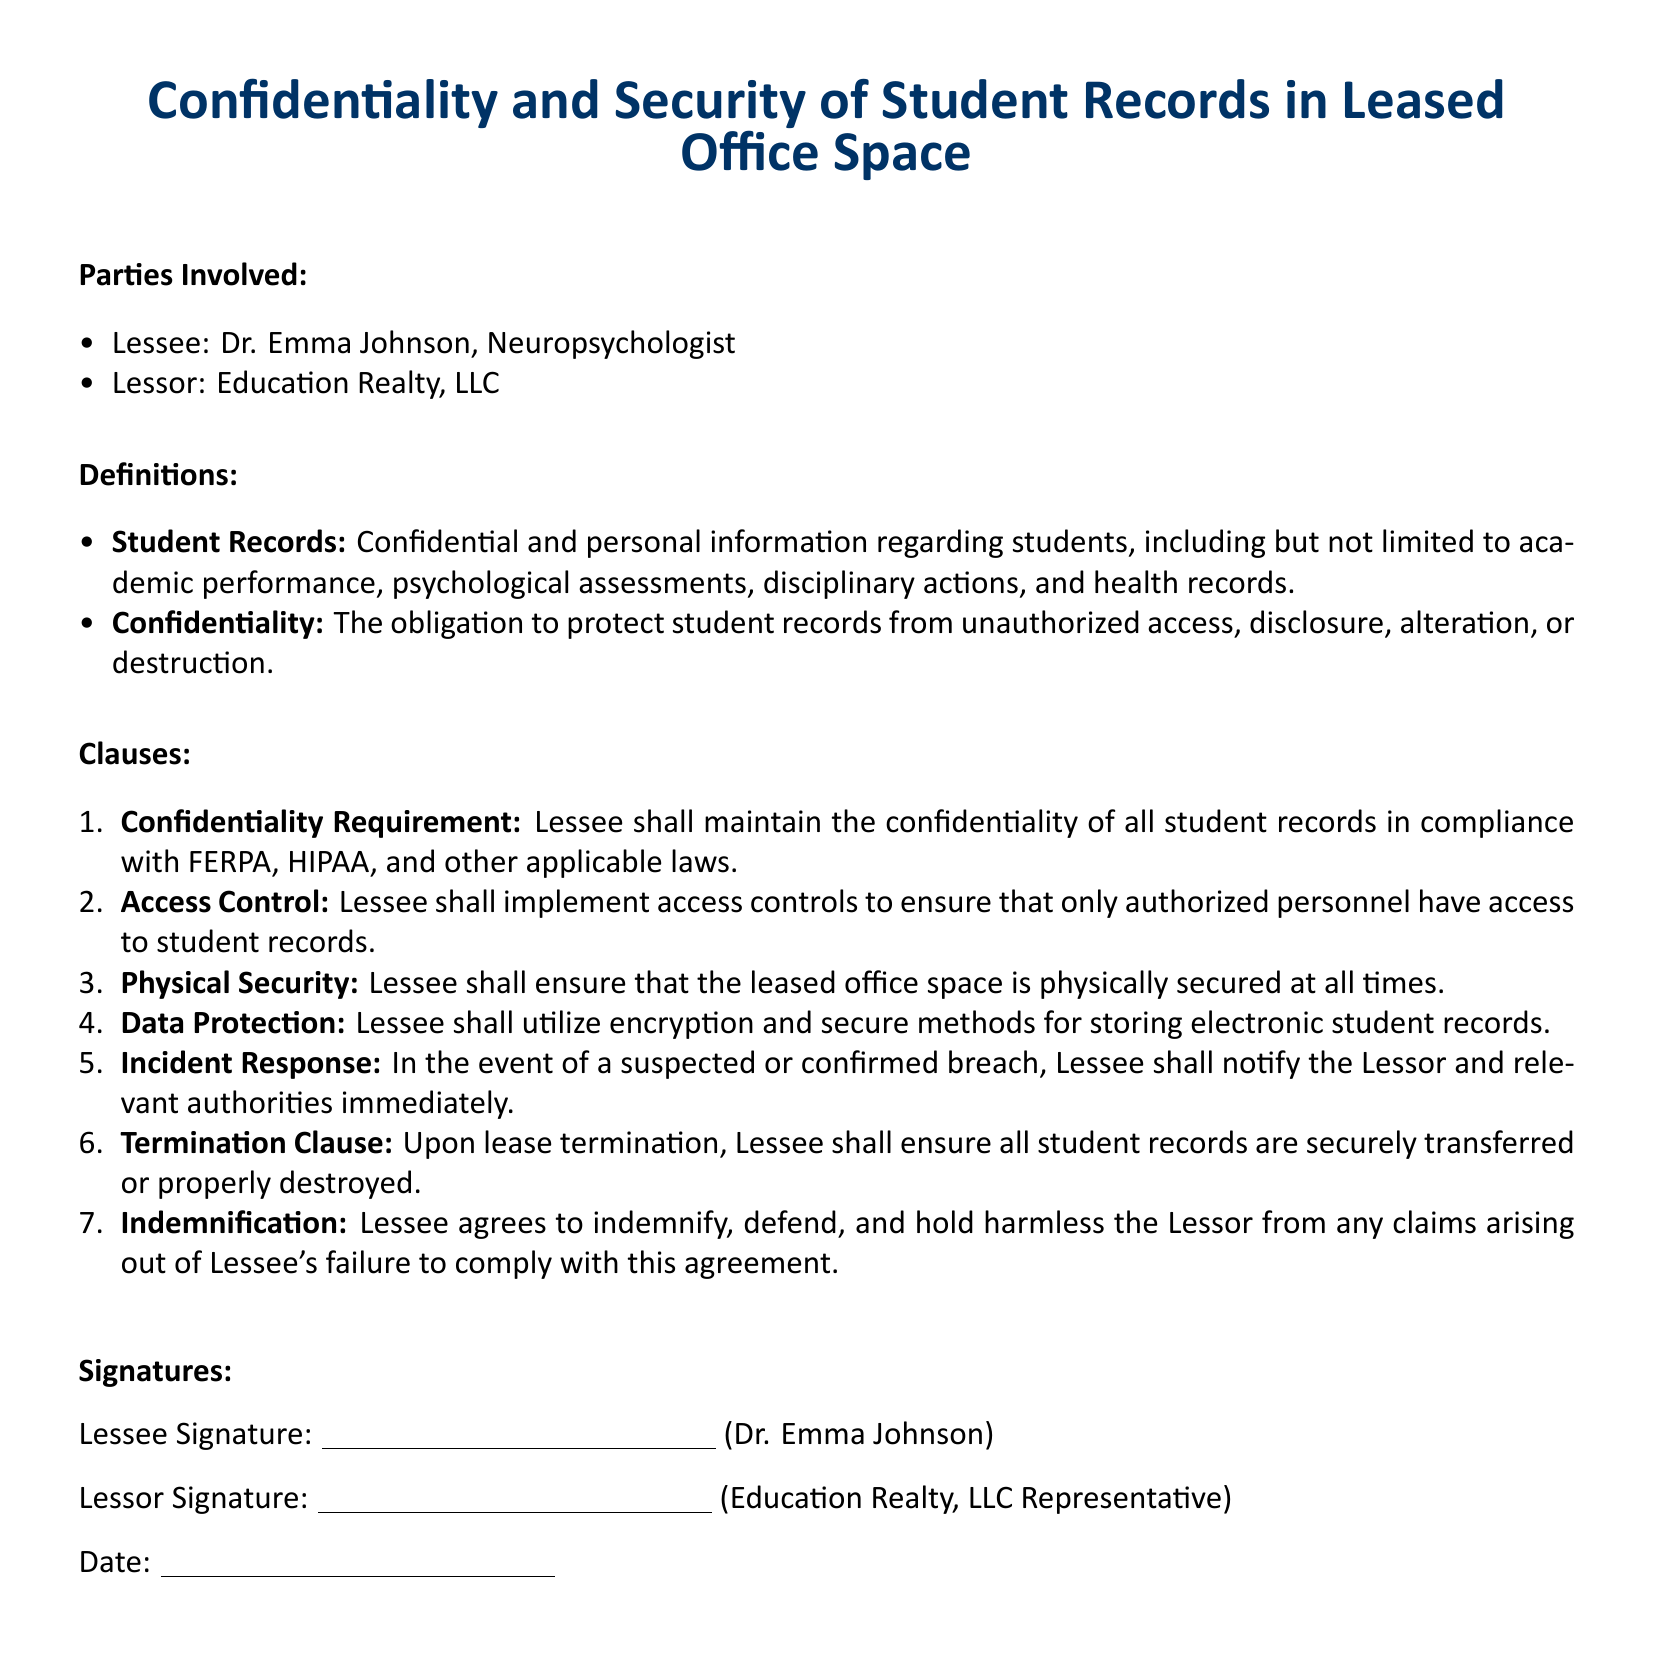What is the name of the Lessee? The Lessee is Dr. Emma Johnson, as mentioned at the beginning of the document.
Answer: Dr. Emma Johnson What does FERPA stand for? FERPA is referenced in the Confidentiality Requirement clause and stands for the Family Educational Rights and Privacy Act.
Answer: Family Educational Rights and Privacy Act Which company is the Lessor? The Lessor is identified in the document as Education Realty, LLC.
Answer: Education Realty, LLC What is one method mentioned for protecting student records? The document specifies that Lessee shall utilize encryption as a method for protecting student records.
Answer: Encryption What must the Lessee do in case of a data breach? The Incident Response clause states that Lessee must notify the Lessor and relevant authorities immediately in the event of a breach.
Answer: Notify immediately What happens to student records upon lease termination? The Termination Clause outlines that the Lessee must ensure all student records are securely transferred or properly destroyed upon termination.
Answer: Securely transferred or properly destroyed What must the Lessee implement for student record access? According to the Access Control clause, the Lessee must implement access controls to ensure authorized personnel only have access.
Answer: Access controls What is the color code used for headings in the document? The primary color code used for headings is RGB (0,51,102).
Answer: RGB (0,51,102) 